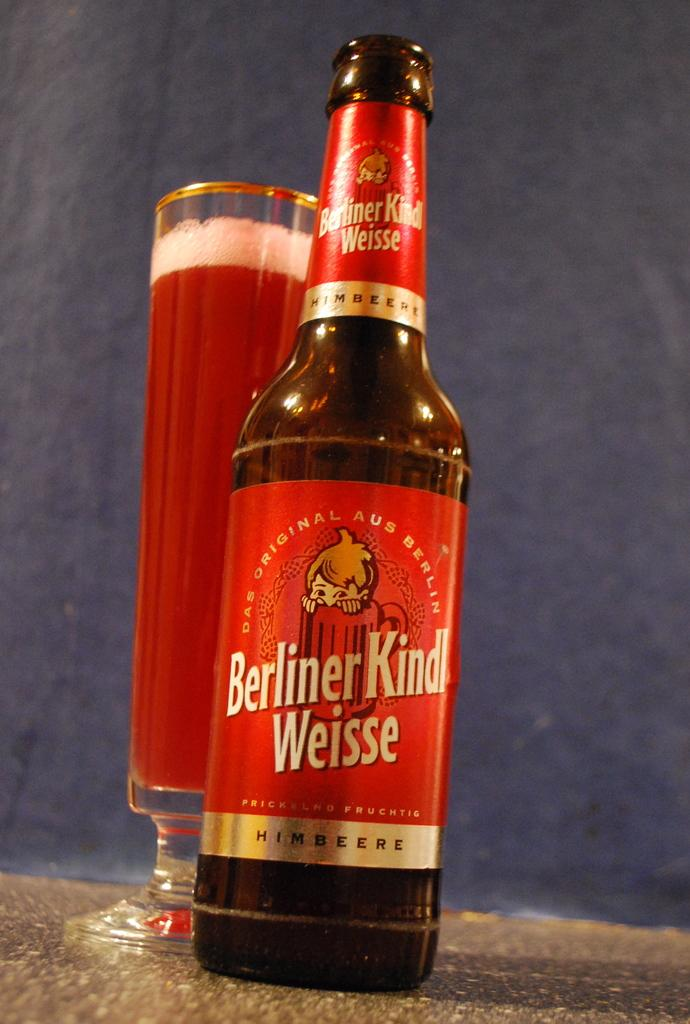Provide a one-sentence caption for the provided image. A close photograph of a bottle reading Berliner Kindl Weisse; behind and slightly to the left of the bottle is a tall, footed glass containing a deep red beverage. 